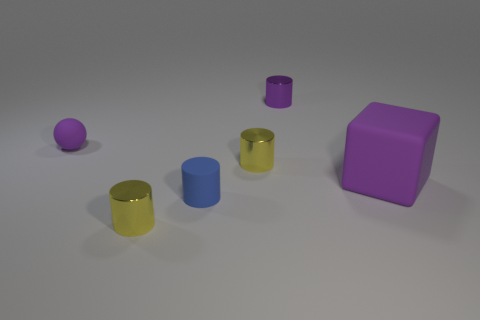There is a metallic thing that is the same color as the ball; what shape is it?
Offer a very short reply. Cylinder. The sphere that is the same color as the big cube is what size?
Ensure brevity in your answer.  Small. There is a big block that is the same color as the matte ball; what material is it?
Provide a succinct answer. Rubber. What number of other objects are there of the same color as the cube?
Make the answer very short. 2. What shape is the metallic object in front of the cube?
Make the answer very short. Cylinder. How many objects are either large cyan matte objects or yellow shiny objects?
Provide a succinct answer. 2. There is a purple rubber cube; is it the same size as the yellow shiny cylinder that is behind the large purple cube?
Your response must be concise. No. How many other things are the same material as the blue cylinder?
Give a very brief answer. 2. How many things are either purple rubber cubes that are behind the blue rubber object or metallic things on the left side of the small rubber cylinder?
Offer a terse response. 2. There is a purple object that is the same shape as the blue thing; what is it made of?
Provide a succinct answer. Metal. 